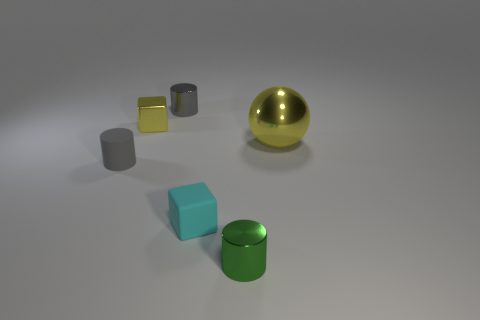Add 3 small cubes. How many objects exist? 9 Subtract all blocks. How many objects are left? 4 Subtract all big yellow matte cylinders. Subtract all metallic balls. How many objects are left? 5 Add 5 big metallic things. How many big metallic things are left? 6 Add 2 purple rubber blocks. How many purple rubber blocks exist? 2 Subtract 0 gray blocks. How many objects are left? 6 